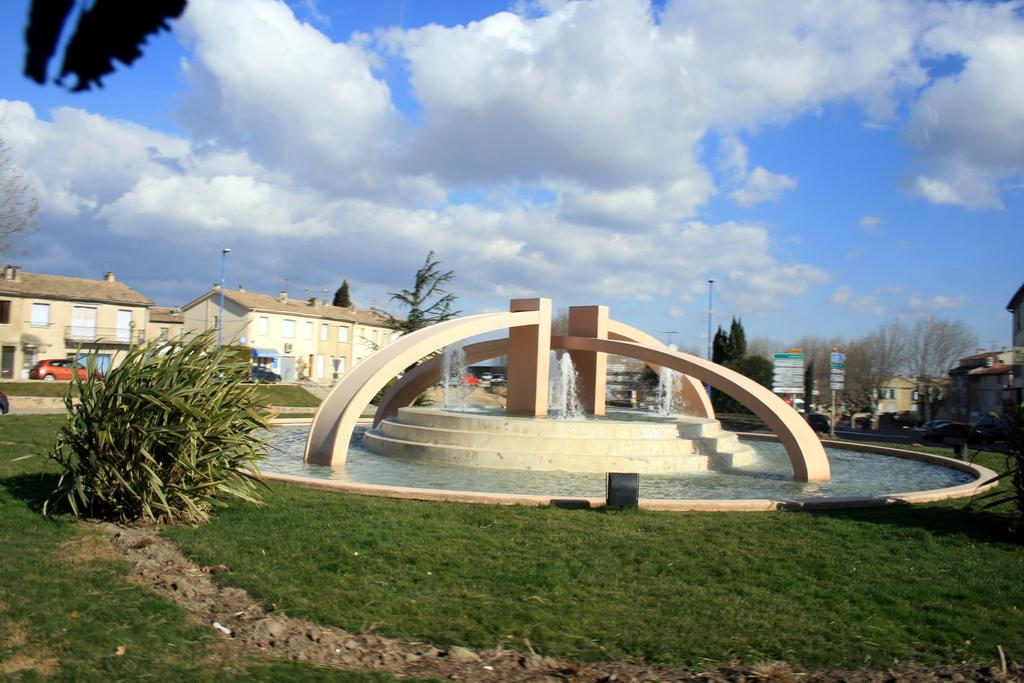What type of vegetation can be seen in the image? There is grass, a plant, and trees visible in the image. What natural element is present in the image? There is water visible in the image. What type of structures are in the image? There are buildings in the image. What is visible in the sky in the image? The sky is visible in the image, and there are clouds present. Can you see a monkey swimming in the water in the image? No, there is no monkey or swimming activity present in the image. 